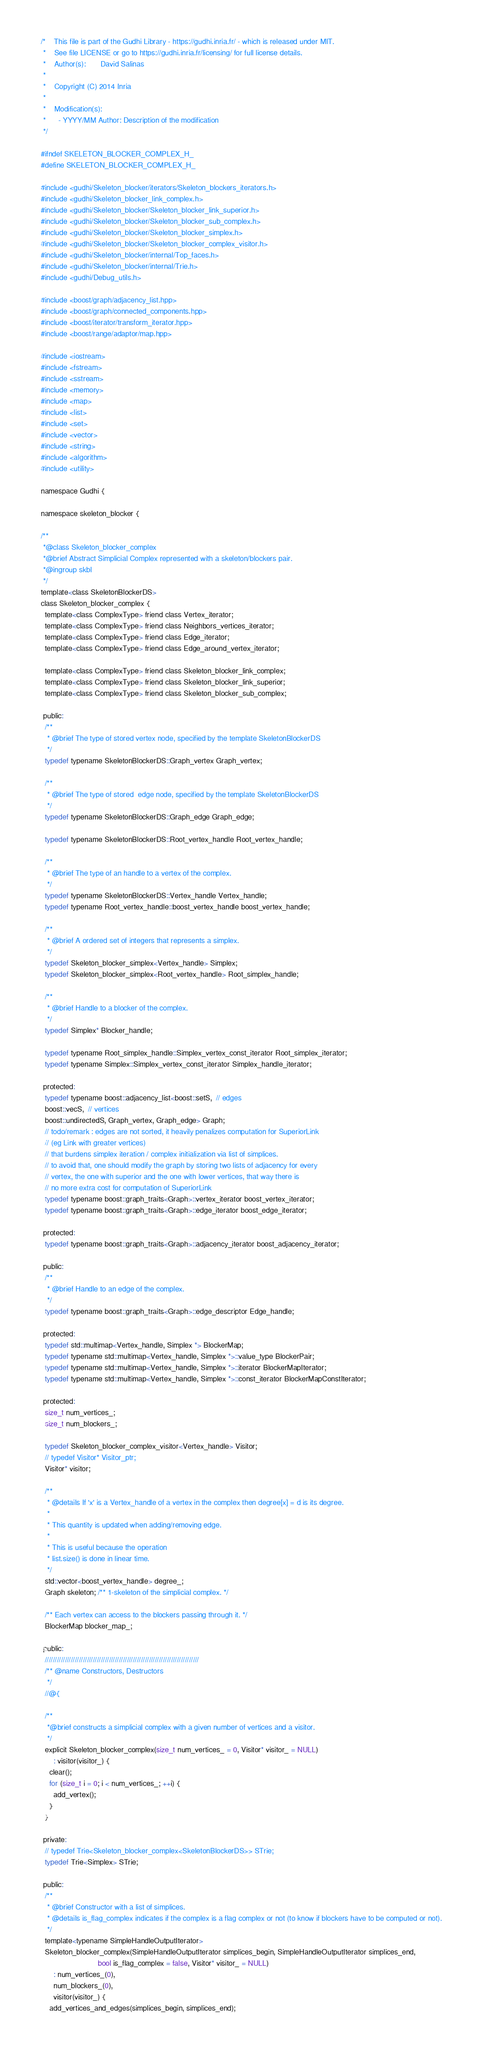<code> <loc_0><loc_0><loc_500><loc_500><_C_>/*    This file is part of the Gudhi Library - https://gudhi.inria.fr/ - which is released under MIT.
 *    See file LICENSE or go to https://gudhi.inria.fr/licensing/ for full license details.
 *    Author(s):       David Salinas
 *
 *    Copyright (C) 2014 Inria
 *
 *    Modification(s):
 *      - YYYY/MM Author: Description of the modification
 */

#ifndef SKELETON_BLOCKER_COMPLEX_H_
#define SKELETON_BLOCKER_COMPLEX_H_

#include <gudhi/Skeleton_blocker/iterators/Skeleton_blockers_iterators.h>
#include <gudhi/Skeleton_blocker_link_complex.h>
#include <gudhi/Skeleton_blocker/Skeleton_blocker_link_superior.h>
#include <gudhi/Skeleton_blocker/Skeleton_blocker_sub_complex.h>
#include <gudhi/Skeleton_blocker/Skeleton_blocker_simplex.h>
#include <gudhi/Skeleton_blocker/Skeleton_blocker_complex_visitor.h>
#include <gudhi/Skeleton_blocker/internal/Top_faces.h>
#include <gudhi/Skeleton_blocker/internal/Trie.h>
#include <gudhi/Debug_utils.h>

#include <boost/graph/adjacency_list.hpp>
#include <boost/graph/connected_components.hpp>
#include <boost/iterator/transform_iterator.hpp>
#include <boost/range/adaptor/map.hpp>

#include <iostream>
#include <fstream>
#include <sstream>
#include <memory>
#include <map>
#include <list>
#include <set>
#include <vector>
#include <string>
#include <algorithm>
#include <utility>

namespace Gudhi {

namespace skeleton_blocker {

/**
 *@class Skeleton_blocker_complex
 *@brief Abstract Simplicial Complex represented with a skeleton/blockers pair.
 *@ingroup skbl
 */
template<class SkeletonBlockerDS>
class Skeleton_blocker_complex {
  template<class ComplexType> friend class Vertex_iterator;
  template<class ComplexType> friend class Neighbors_vertices_iterator;
  template<class ComplexType> friend class Edge_iterator;
  template<class ComplexType> friend class Edge_around_vertex_iterator;

  template<class ComplexType> friend class Skeleton_blocker_link_complex;
  template<class ComplexType> friend class Skeleton_blocker_link_superior;
  template<class ComplexType> friend class Skeleton_blocker_sub_complex;

 public:
  /**
   * @brief The type of stored vertex node, specified by the template SkeletonBlockerDS
   */
  typedef typename SkeletonBlockerDS::Graph_vertex Graph_vertex;

  /**
   * @brief The type of stored  edge node, specified by the template SkeletonBlockerDS
   */
  typedef typename SkeletonBlockerDS::Graph_edge Graph_edge;

  typedef typename SkeletonBlockerDS::Root_vertex_handle Root_vertex_handle;

  /**
   * @brief The type of an handle to a vertex of the complex.
   */
  typedef typename SkeletonBlockerDS::Vertex_handle Vertex_handle;
  typedef typename Root_vertex_handle::boost_vertex_handle boost_vertex_handle;

  /**
   * @brief A ordered set of integers that represents a simplex.
   */
  typedef Skeleton_blocker_simplex<Vertex_handle> Simplex;
  typedef Skeleton_blocker_simplex<Root_vertex_handle> Root_simplex_handle;

  /**
   * @brief Handle to a blocker of the complex.
   */
  typedef Simplex* Blocker_handle;

  typedef typename Root_simplex_handle::Simplex_vertex_const_iterator Root_simplex_iterator;
  typedef typename Simplex::Simplex_vertex_const_iterator Simplex_handle_iterator;

 protected:
  typedef typename boost::adjacency_list<boost::setS,  // edges
  boost::vecS,  // vertices
  boost::undirectedS, Graph_vertex, Graph_edge> Graph;
  // todo/remark : edges are not sorted, it heavily penalizes computation for SuperiorLink
  // (eg Link with greater vertices)
  // that burdens simplex iteration / complex initialization via list of simplices.
  // to avoid that, one should modify the graph by storing two lists of adjacency for every
  // vertex, the one with superior and the one with lower vertices, that way there is
  // no more extra cost for computation of SuperiorLink
  typedef typename boost::graph_traits<Graph>::vertex_iterator boost_vertex_iterator;
  typedef typename boost::graph_traits<Graph>::edge_iterator boost_edge_iterator;

 protected:
  typedef typename boost::graph_traits<Graph>::adjacency_iterator boost_adjacency_iterator;

 public:
  /**
   * @brief Handle to an edge of the complex.
   */
  typedef typename boost::graph_traits<Graph>::edge_descriptor Edge_handle;

 protected:
  typedef std::multimap<Vertex_handle, Simplex *> BlockerMap;
  typedef typename std::multimap<Vertex_handle, Simplex *>::value_type BlockerPair;
  typedef typename std::multimap<Vertex_handle, Simplex *>::iterator BlockerMapIterator;
  typedef typename std::multimap<Vertex_handle, Simplex *>::const_iterator BlockerMapConstIterator;

 protected:
  size_t num_vertices_;
  size_t num_blockers_;

  typedef Skeleton_blocker_complex_visitor<Vertex_handle> Visitor;
  // typedef Visitor* Visitor_ptr;
  Visitor* visitor;

  /**
   * @details If 'x' is a Vertex_handle of a vertex in the complex then degree[x] = d is its degree.
   *
   * This quantity is updated when adding/removing edge.
   *
   * This is useful because the operation
   * list.size() is done in linear time.
   */
  std::vector<boost_vertex_handle> degree_;
  Graph skeleton; /** 1-skeleton of the simplicial complex. */

  /** Each vertex can access to the blockers passing through it. */
  BlockerMap blocker_map_;

 public:
  /////////////////////////////////////////////////////////////////////////////
  /** @name Constructors, Destructors
   */
  //@{

  /**
   *@brief constructs a simplicial complex with a given number of vertices and a visitor.
   */
  explicit Skeleton_blocker_complex(size_t num_vertices_ = 0, Visitor* visitor_ = NULL)
      : visitor(visitor_) {
    clear();
    for (size_t i = 0; i < num_vertices_; ++i) {
      add_vertex();
    }
  }

 private:
  // typedef Trie<Skeleton_blocker_complex<SkeletonBlockerDS>> STrie;
  typedef Trie<Simplex> STrie;

 public:
  /**
   * @brief Constructor with a list of simplices.
   * @details is_flag_complex indicates if the complex is a flag complex or not (to know if blockers have to be computed or not).
   */
  template<typename SimpleHandleOutputIterator>
  Skeleton_blocker_complex(SimpleHandleOutputIterator simplices_begin, SimpleHandleOutputIterator simplices_end,
                           bool is_flag_complex = false, Visitor* visitor_ = NULL)
      : num_vertices_(0),
      num_blockers_(0),
      visitor(visitor_) {
    add_vertices_and_edges(simplices_begin, simplices_end);
</code> 